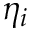<formula> <loc_0><loc_0><loc_500><loc_500>\eta _ { i }</formula> 